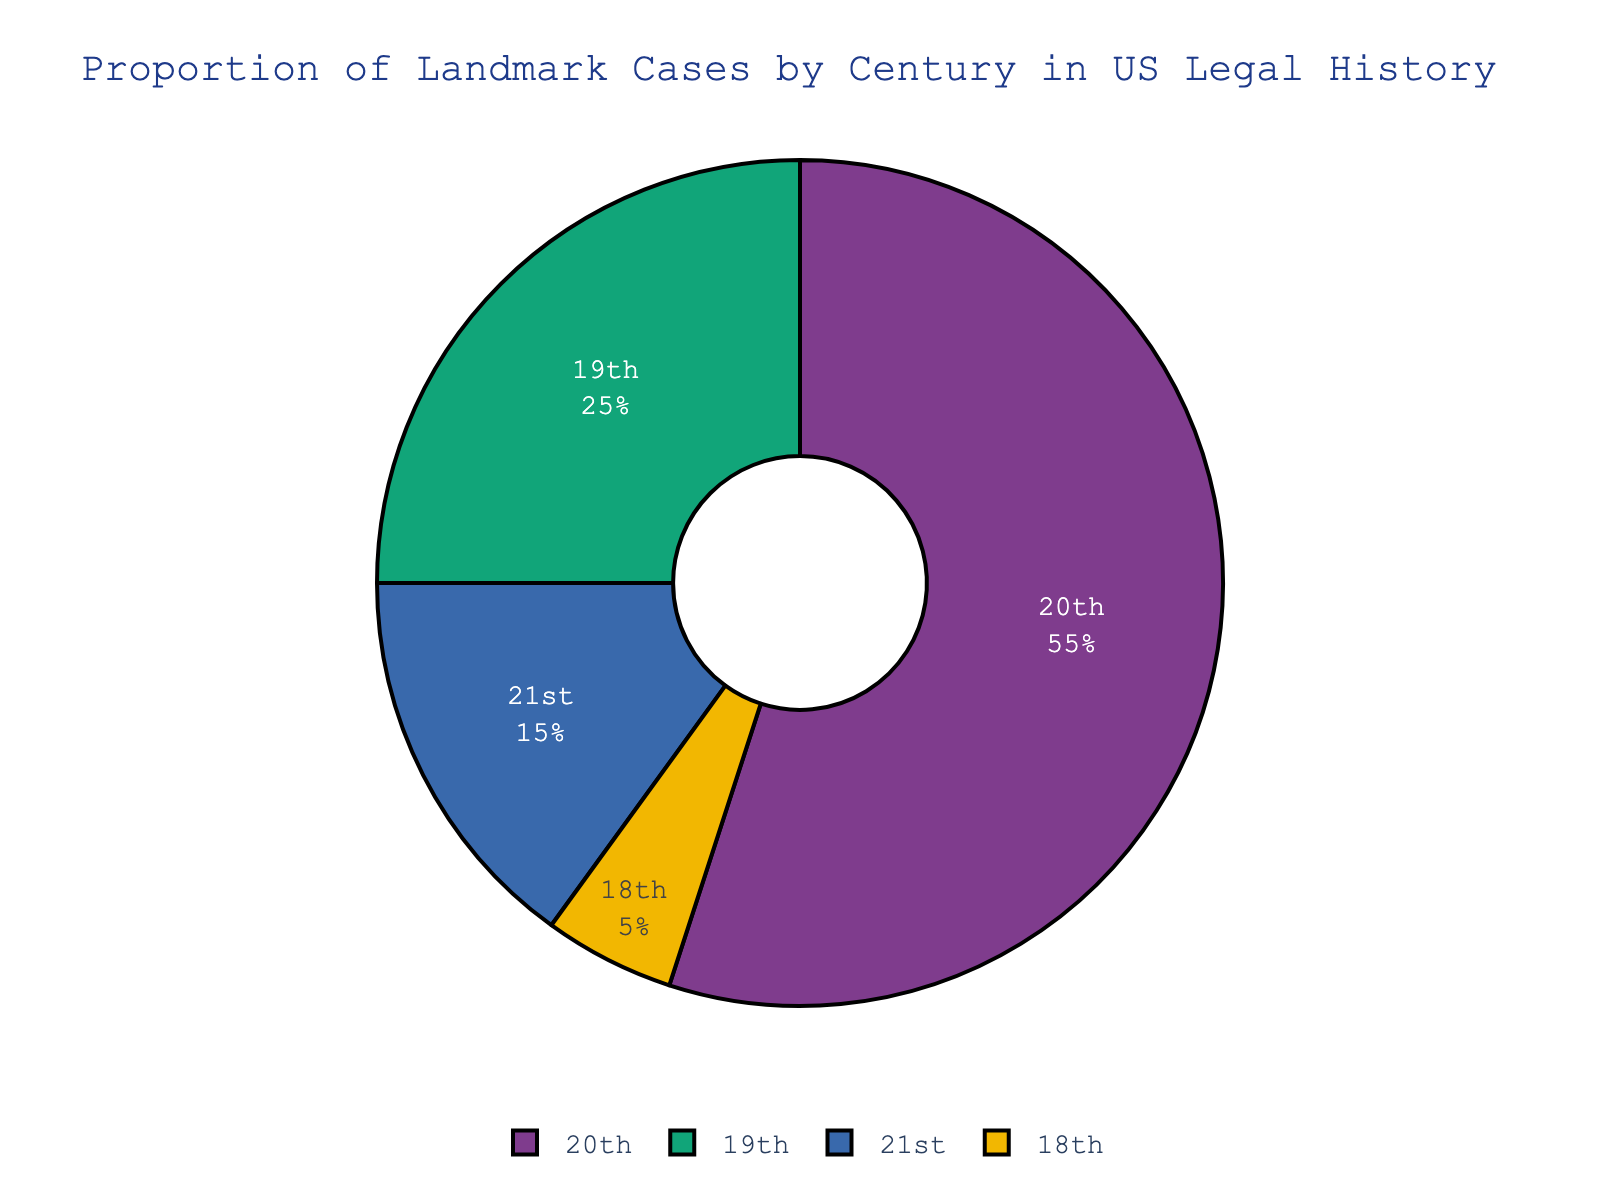What century has the highest proportion of landmark cases? The pie chart shows that the 20th century has the largest segment, indicating the highest proportion.
Answer: 20th century What is the combined proportion of landmark cases for the 18th and 21st centuries? The 18th century has 5%, and the 21st century has 15%. Adding these gives 5% + 15% = 20%.
Answer: 20% Which century has fewer landmark cases, the 18th or the 21st century? The pie chart shows that the 18th century has a smaller segment (5%) compared to the 21st century (15%).
Answer: 18th century How much higher is the proportion of landmark cases in the 20th century compared to the 19th century? The 20th century has 55%, and the 19th century has 25%. The difference is 55% - 25% = 30%.
Answer: 30% What is the second most represented century in terms of landmark cases? The pie chart shows that the 20th century has the most at 55%, followed by the 19th century with 25%.
Answer: 19th century How do the proportions of the 21st and 19th centuries compare in terms of landmark cases? The pie chart shows that the 19th century has 25%, while the 21st century has 15%. Thus, the 19th century has a greater proportion of landmark cases.
Answer: 19th century What percent of centuries have a proportion of landmark cases that is less than 20%? The 18th and the 21st centuries both have proportions less than 20%, so that's 2 out of 4 centuries. The calculation is (2/4) * 100 = 50%.
Answer: 50% Which segment is smaller in size, the 18th century or the 21st century? The pie chart shows the 18th century with 5% and the 21st century with 15%. Therefore, the 18th century segment is smaller.
Answer: 18th century What is the average proportion of landmark cases across all four centuries? Add all proportions: 5% + 25% + 55% + 15% = 100%. Then, the average is 100% / 4 = 25%.
Answer: 25% 